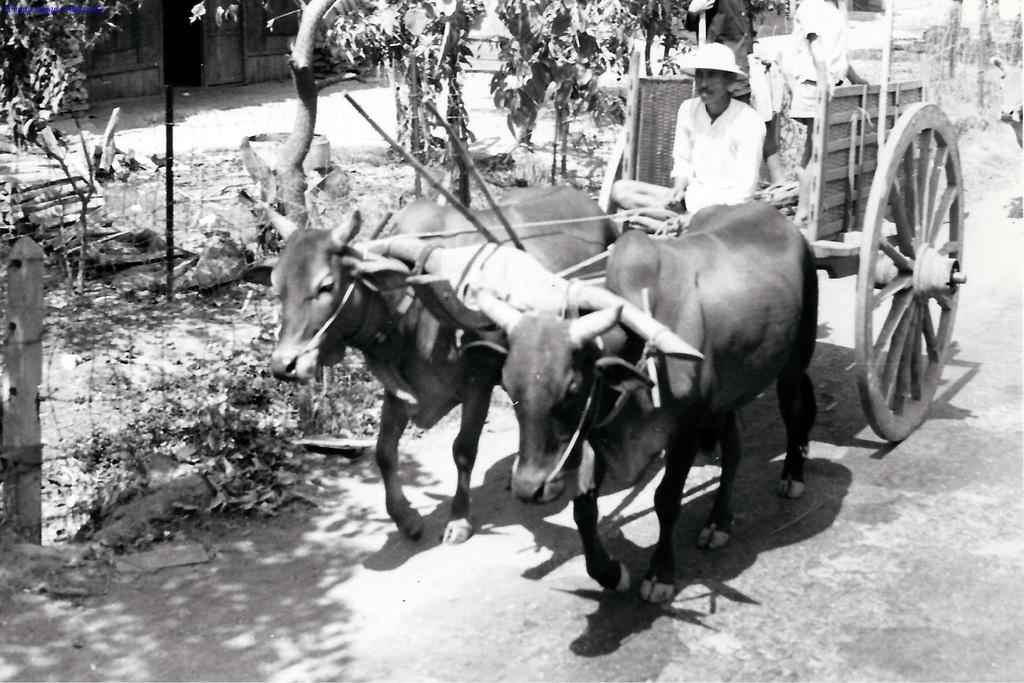What type of vehicle is in the image? There is a bullock cart in the image. What is pulling the cart? Two bulls are pulling the cart. Who is sitting on the cart? There is a man sitting on the cart. What is the man wearing on his head? The man is wearing a hat. What can be seen beside the cart? There are plants beside the cart. What type of material is visible in the image? There is fencing wire visible in the image. What type of natural scenery is present in the image? There are trees in the image. Can you tell me how many basketballs are being used by the man in the image? There are no basketballs present in the image; the man is sitting on a bullock cart. 